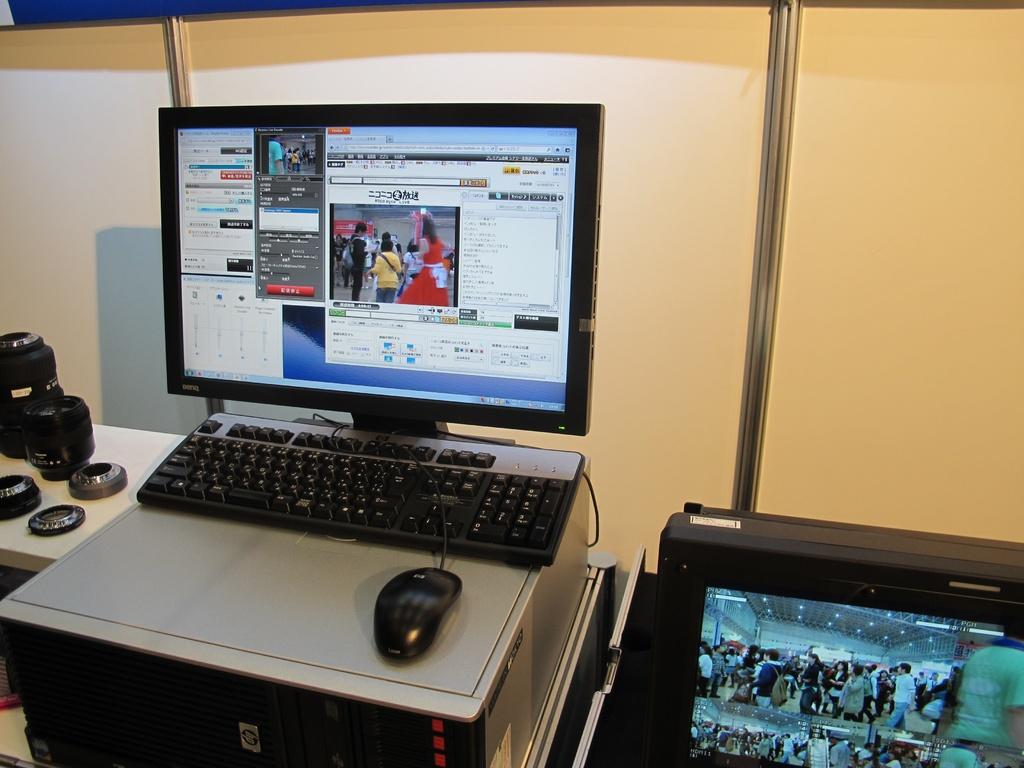What electronic device is on the table in the image? There is a computer on the table in the image. What other item related to photography can be seen on the table? There is a camera lens on the table. Is there a display device on the table? Yes, there is a small screen on the table. What flavor of paper is on the table in the image? There is no paper present in the image, and therefore no flavor can be associated with it. 